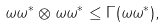Convert formula to latex. <formula><loc_0><loc_0><loc_500><loc_500>\omega \omega ^ { * } \otimes \omega \omega ^ { * } \leq \Gamma ( \omega \omega ^ { * } ) ,</formula> 